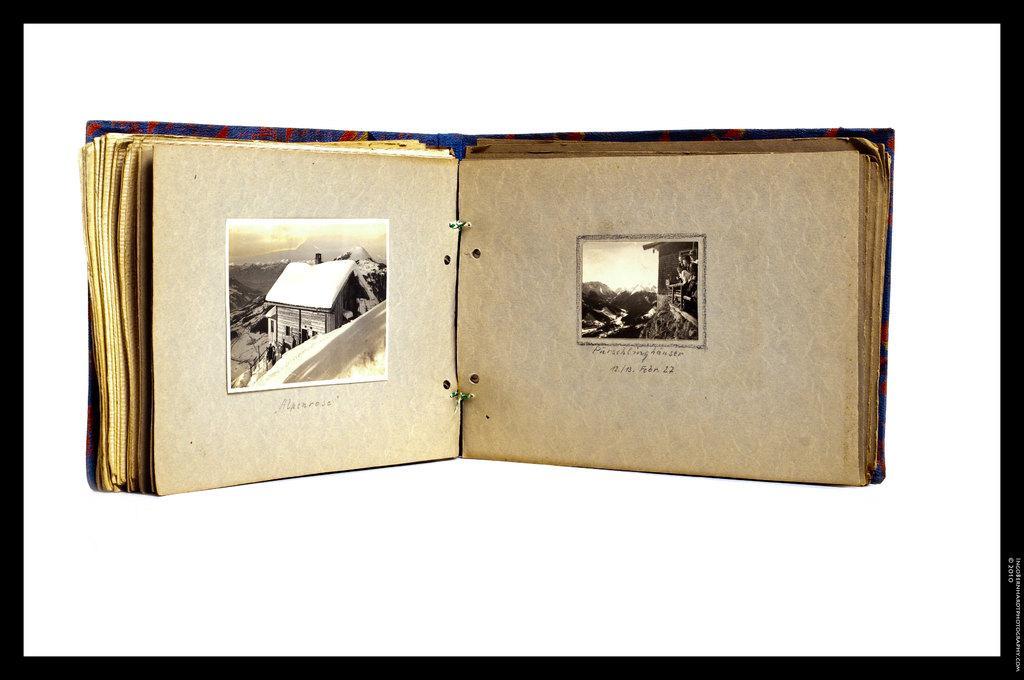Could you give a brief overview of what you see in this image? In this picture we can see a book. Here we can see a house and sky. 